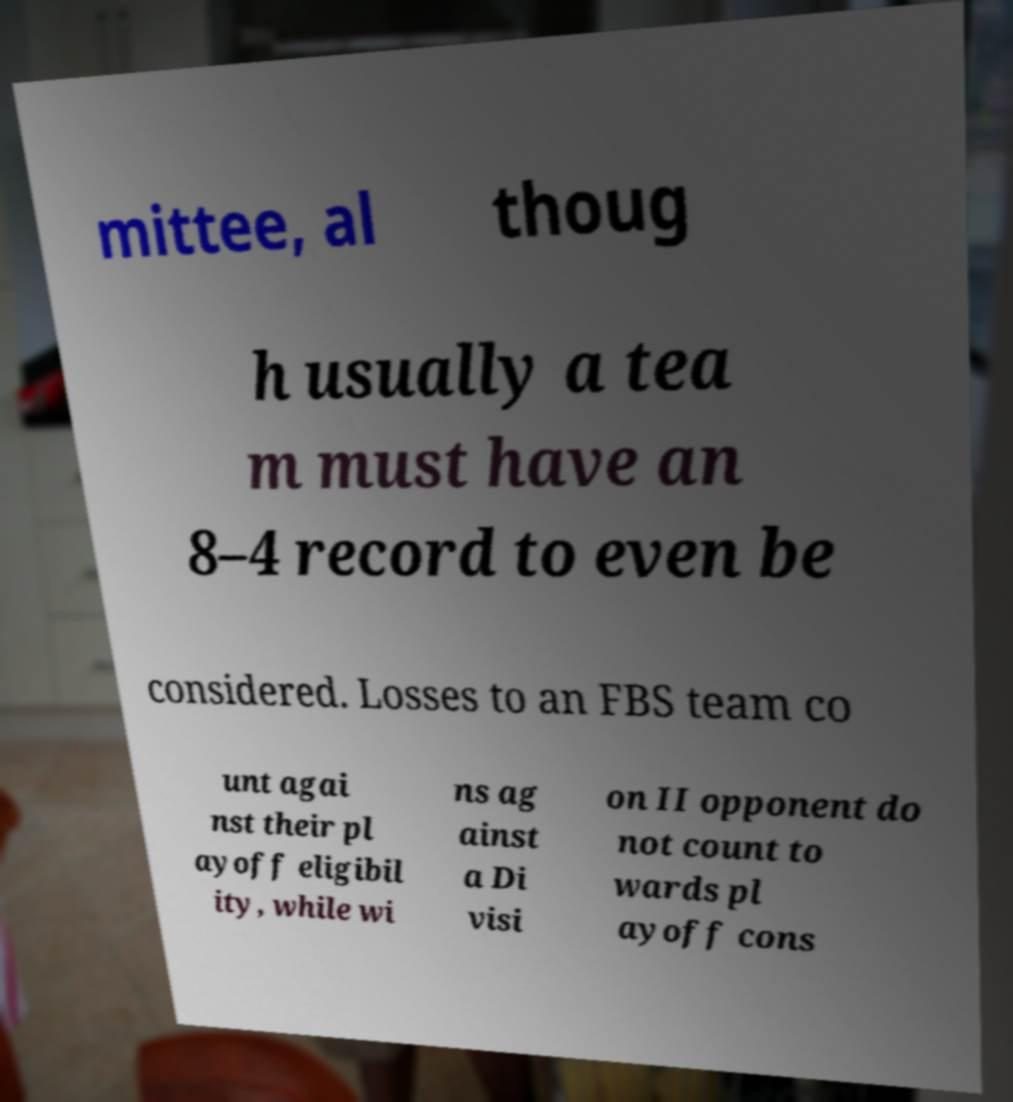Could you assist in decoding the text presented in this image and type it out clearly? mittee, al thoug h usually a tea m must have an 8–4 record to even be considered. Losses to an FBS team co unt agai nst their pl ayoff eligibil ity, while wi ns ag ainst a Di visi on II opponent do not count to wards pl ayoff cons 